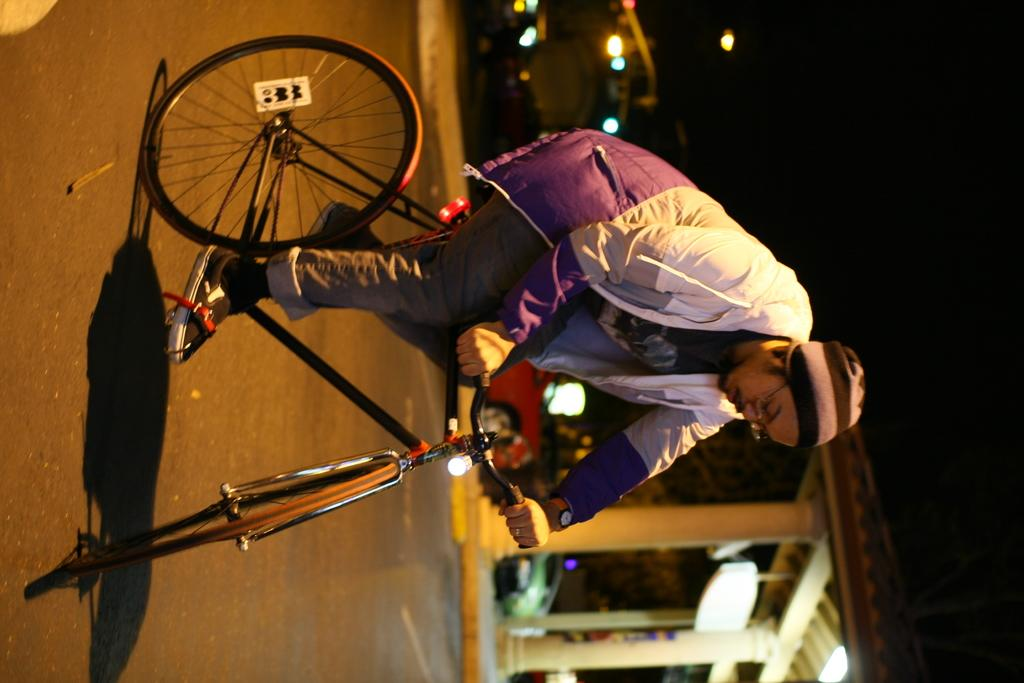What is the main subject of the image? There is a man in the image. What is the man wearing on his head? The man is wearing a cap. What is the man wearing on his face? The man is wearing spectacles. What is the man doing in the image? The man is riding a bicycle. Where is the bicycle located? The bicycle is on the road. What can be seen in the background of the image? There is a shed and a light in the background of the image. How many toes can be seen on the man's foot in the image? There is no visible foot or toes of the man in the image. What type of pest is causing trouble for the man in the image? There is no pest present in the image, and the man is not experiencing any trouble. 